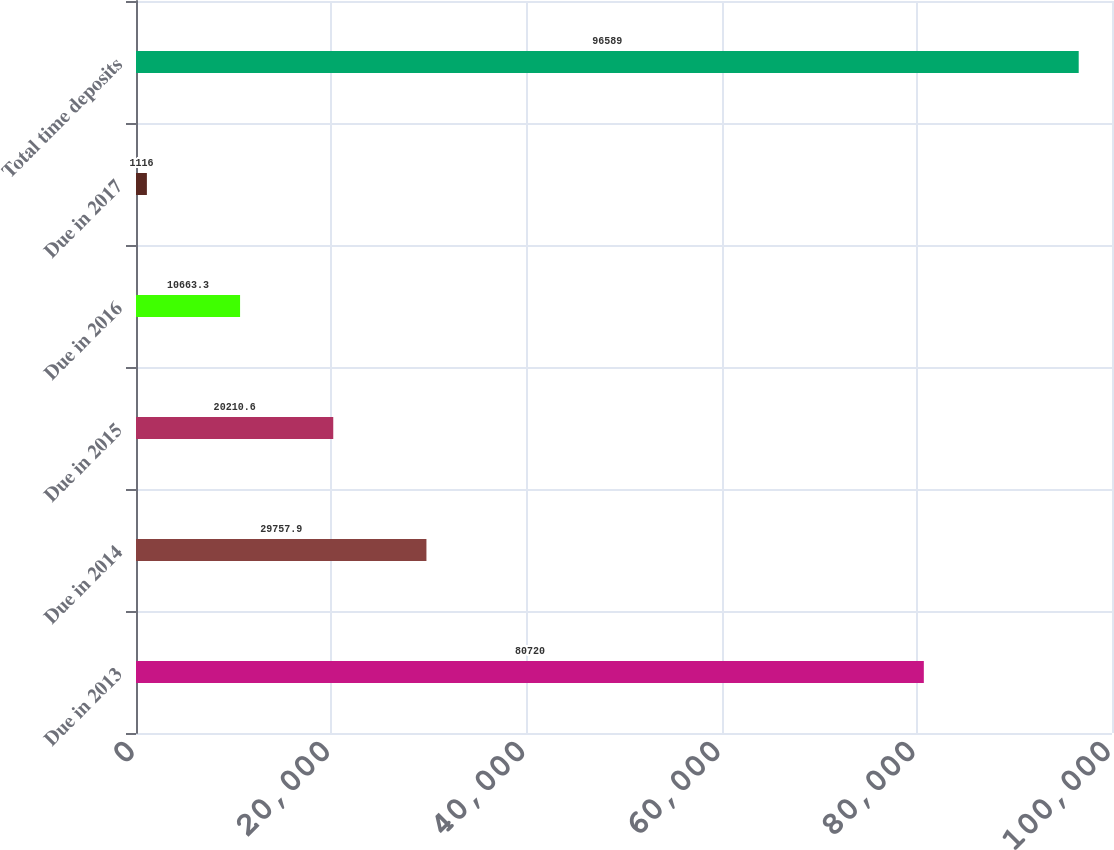Convert chart. <chart><loc_0><loc_0><loc_500><loc_500><bar_chart><fcel>Due in 2013<fcel>Due in 2014<fcel>Due in 2015<fcel>Due in 2016<fcel>Due in 2017<fcel>Total time deposits<nl><fcel>80720<fcel>29757.9<fcel>20210.6<fcel>10663.3<fcel>1116<fcel>96589<nl></chart> 